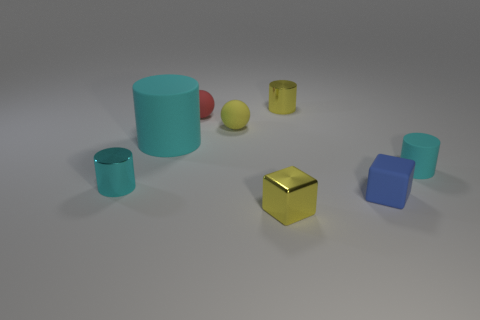Are there fewer matte cylinders than small cyan matte things?
Your response must be concise. No. There is a cyan shiny object that is the same shape as the tiny cyan rubber thing; what size is it?
Offer a terse response. Small. Is the material of the big cylinder that is left of the red thing the same as the small red ball?
Provide a succinct answer. Yes. Do the red thing and the large cyan rubber thing have the same shape?
Your answer should be very brief. No. What number of objects are either small metallic things on the right side of the small cyan metallic cylinder or brown matte blocks?
Give a very brief answer. 2. What number of things are the same color as the metallic cube?
Give a very brief answer. 2. How many large objects are yellow blocks or balls?
Your answer should be compact. 0. What size is the other matte cylinder that is the same color as the tiny rubber cylinder?
Your response must be concise. Large. Is there a tiny yellow sphere made of the same material as the small red object?
Offer a terse response. Yes. There is a tiny cyan cylinder on the right side of the small blue rubber cube; what is its material?
Make the answer very short. Rubber. 